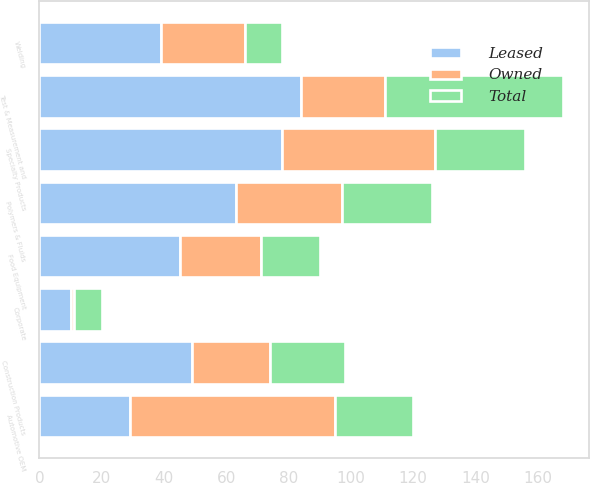Convert chart to OTSL. <chart><loc_0><loc_0><loc_500><loc_500><stacked_bar_chart><ecel><fcel>Automotive OEM<fcel>Food Equipment<fcel>Test & Measurement and<fcel>Welding<fcel>Polymers & Fluids<fcel>Construction Products<fcel>Specialty Products<fcel>Corporate<nl><fcel>Owned<fcel>66<fcel>26<fcel>27<fcel>27<fcel>34<fcel>25<fcel>49<fcel>1<nl><fcel>Total<fcel>25<fcel>19<fcel>57<fcel>12<fcel>29<fcel>24<fcel>29<fcel>9<nl><fcel>Leased<fcel>29<fcel>45<fcel>84<fcel>39<fcel>63<fcel>49<fcel>78<fcel>10<nl></chart> 